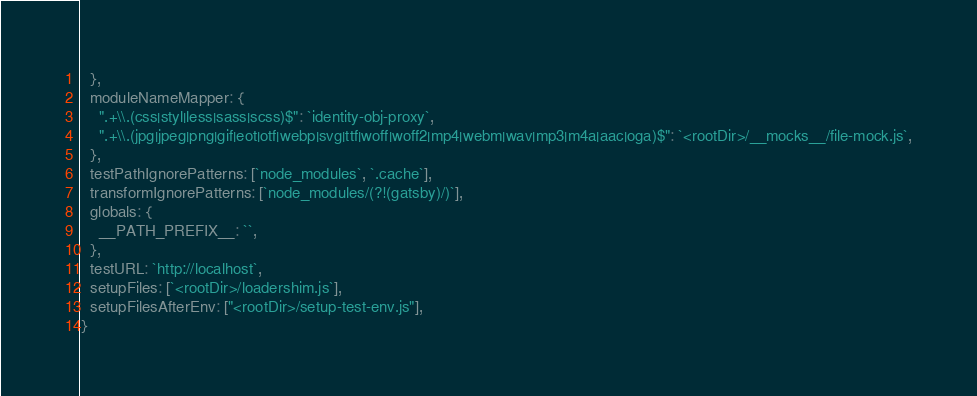<code> <loc_0><loc_0><loc_500><loc_500><_JavaScript_>  },
  moduleNameMapper: {
    ".+\\.(css|styl|less|sass|scss)$": `identity-obj-proxy`,
    ".+\\.(jpg|jpeg|png|gif|eot|otf|webp|svg|ttf|woff|woff2|mp4|webm|wav|mp3|m4a|aac|oga)$": `<rootDir>/__mocks__/file-mock.js`,
  },
  testPathIgnorePatterns: [`node_modules`, `.cache`],
  transformIgnorePatterns: [`node_modules/(?!(gatsby)/)`],
  globals: {
    __PATH_PREFIX__: ``,
  },
  testURL: `http://localhost`,
  setupFiles: [`<rootDir>/loadershim.js`],
  setupFilesAfterEnv: ["<rootDir>/setup-test-env.js"],
}
</code> 